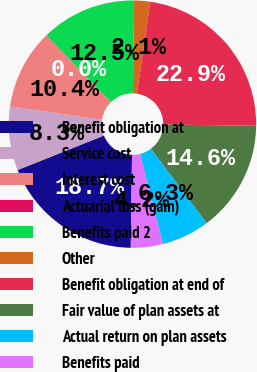<chart> <loc_0><loc_0><loc_500><loc_500><pie_chart><fcel>Benefit obligation at<fcel>Service cost<fcel>Interest cost<fcel>Actuarial loss (gain)<fcel>Benefits paid 2<fcel>Other<fcel>Benefit obligation at end of<fcel>Fair value of plan assets at<fcel>Actual return on plan assets<fcel>Benefits paid<nl><fcel>18.73%<fcel>8.34%<fcel>10.42%<fcel>0.02%<fcel>12.49%<fcel>2.1%<fcel>22.89%<fcel>14.57%<fcel>6.26%<fcel>4.18%<nl></chart> 